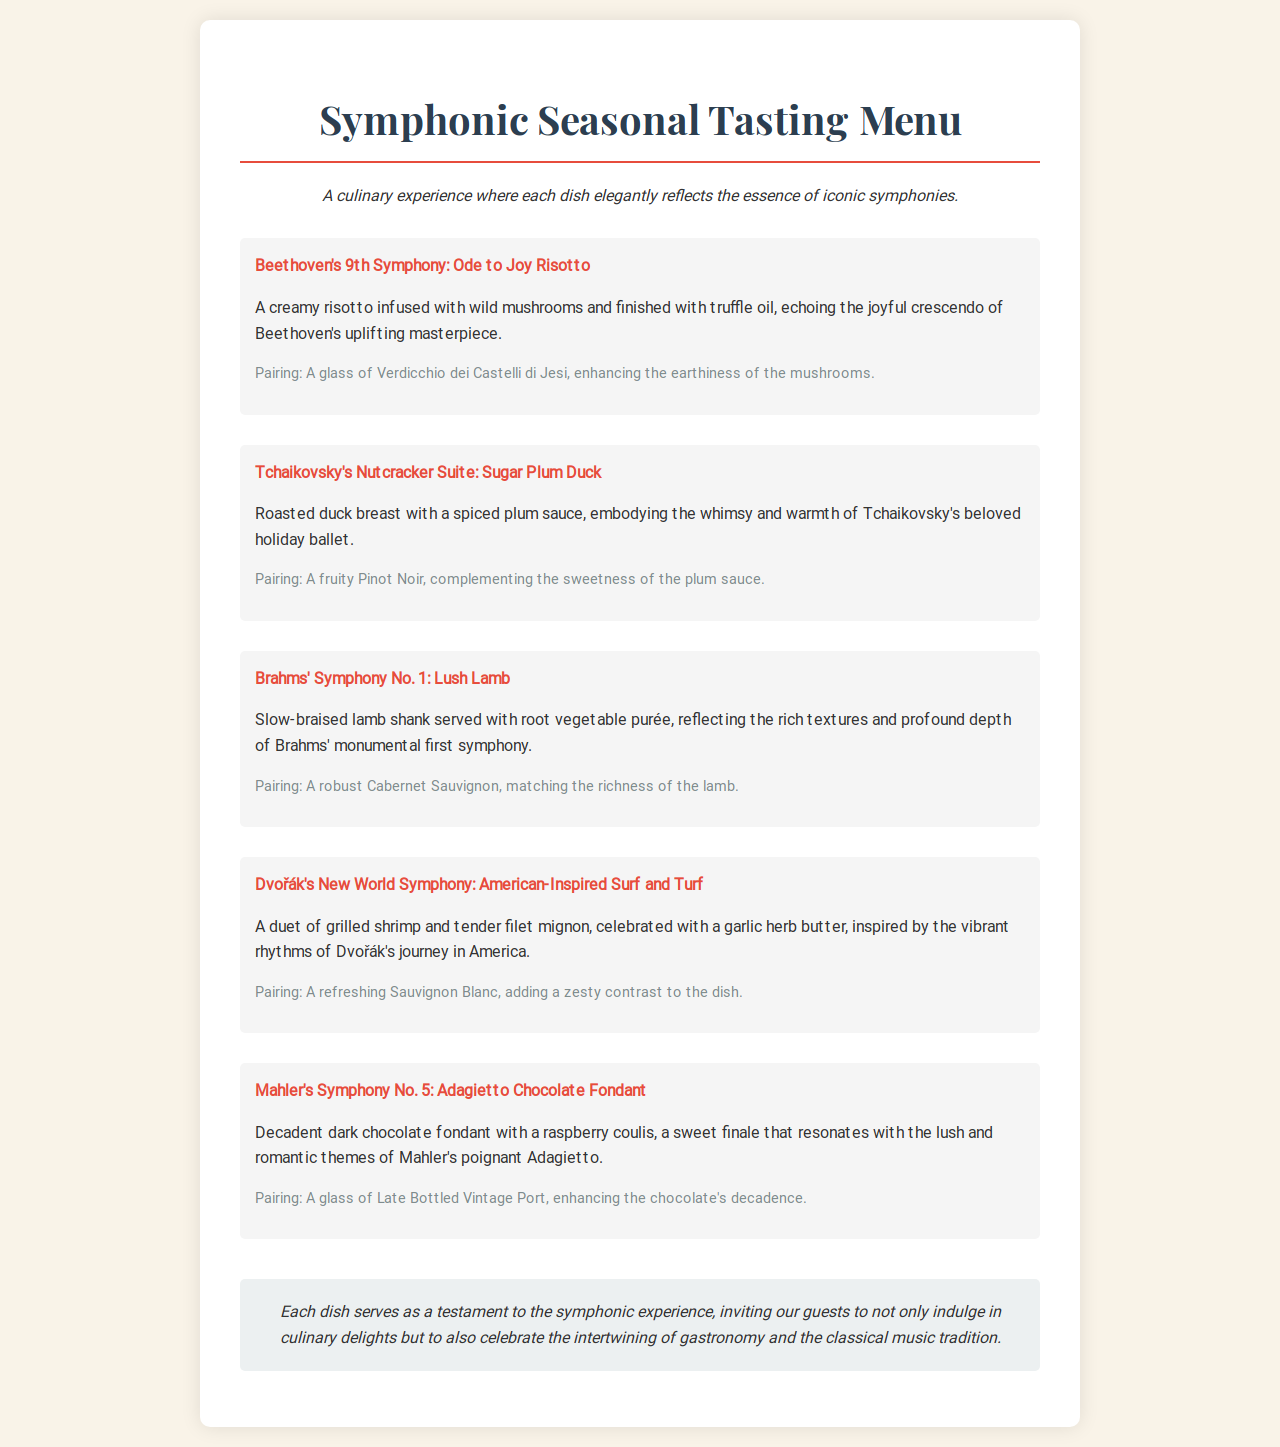what is the title of the menu? The title of the menu is prominently displayed at the top of the document as "Symphonic Seasonal Tasting Menu."
Answer: Symphonic Seasonal Tasting Menu how many dishes are featured in the menu? The menu includes five distinct dishes, each inspired by a different symphony.
Answer: Five which dish is paired with a glass of Verdicchio dei Castelli di Jesi? The dish paired with a glass of Verdicchio dei Castelli di Jesi is "Beethoven's 9th Symphony: Ode to Joy Risotto."
Answer: Beethoven's 9th Symphony: Ode to Joy Risotto what is the main protein used in Dvořák's New World Symphony dish? The main protein in Dvořák's New World Symphony dish is filet mignon and grilled shrimp.
Answer: Filet mignon and grilled shrimp what flavor profiles does the Mahler's Symphony No. 5 dessert represent? Mahler's Symphony No. 5 dessert represents decadence and sweetness, accompanied by the lush and romantic themes of Mahler's work.
Answer: Decadence and sweetness which symphony does the "Sugar Plum Duck" represent? "Sugar Plum Duck" is a dish inspired by Tchaikovsky's Nutcracker Suite.
Answer: Tchaikovsky's Nutcracker Suite what type of wine is suggested with the Lush Lamb dish? The suggested wine pairing with the Lush Lamb dish is a robust Cabernet Sauvignon.
Answer: Cabernet Sauvignon which dish reflects the rich textures of Brahms' first symphony? The dish that reflects the rich textures of Brahms' first symphony is "Lush Lamb."
Answer: Lush Lamb 